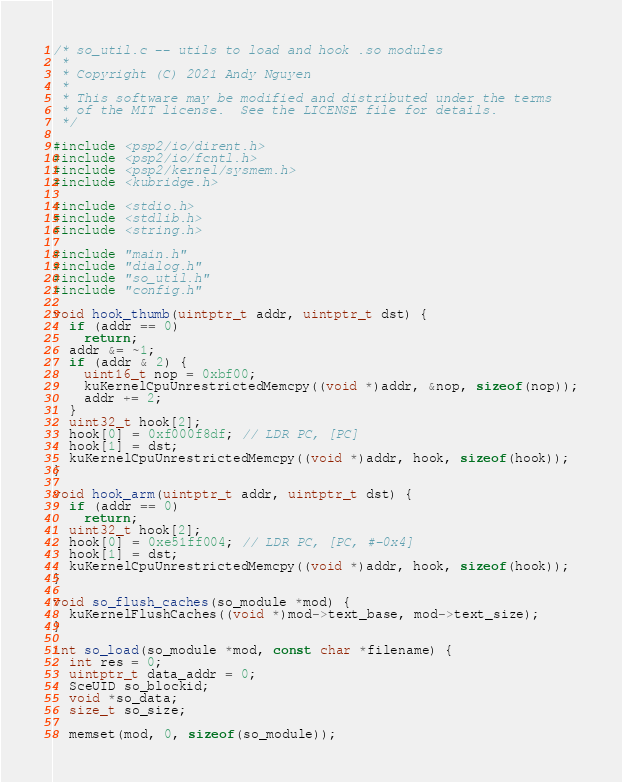Convert code to text. <code><loc_0><loc_0><loc_500><loc_500><_C_>/* so_util.c -- utils to load and hook .so modules
 *
 * Copyright (C) 2021 Andy Nguyen
 *
 * This software may be modified and distributed under the terms
 * of the MIT license.  See the LICENSE file for details.
 */

#include <psp2/io/dirent.h>
#include <psp2/io/fcntl.h>
#include <psp2/kernel/sysmem.h>
#include <kubridge.h>

#include <stdio.h>
#include <stdlib.h>
#include <string.h>

#include "main.h"
#include "dialog.h"
#include "so_util.h"
#include "config.h"

void hook_thumb(uintptr_t addr, uintptr_t dst) {
  if (addr == 0)
    return;
  addr &= ~1;
  if (addr & 2) {
    uint16_t nop = 0xbf00;
    kuKernelCpuUnrestrictedMemcpy((void *)addr, &nop, sizeof(nop));
    addr += 2;
  }
  uint32_t hook[2];
  hook[0] = 0xf000f8df; // LDR PC, [PC]
  hook[1] = dst;
  kuKernelCpuUnrestrictedMemcpy((void *)addr, hook, sizeof(hook));
}

void hook_arm(uintptr_t addr, uintptr_t dst) {
  if (addr == 0)
    return;
  uint32_t hook[2];
  hook[0] = 0xe51ff004; // LDR PC, [PC, #-0x4]
  hook[1] = dst;
  kuKernelCpuUnrestrictedMemcpy((void *)addr, hook, sizeof(hook));
}

void so_flush_caches(so_module *mod) {
  kuKernelFlushCaches((void *)mod->text_base, mod->text_size);
}

int so_load(so_module *mod, const char *filename) {
  int res = 0;
  uintptr_t data_addr = 0;
  SceUID so_blockid;
  void *so_data;
  size_t so_size;

  memset(mod, 0, sizeof(so_module));
</code> 